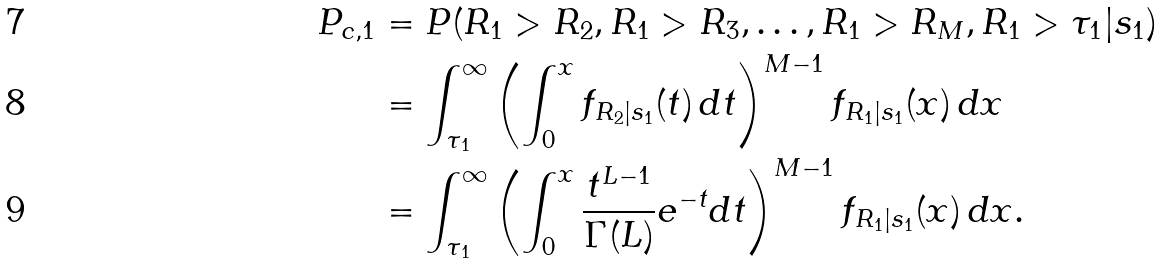<formula> <loc_0><loc_0><loc_500><loc_500>P _ { c , 1 } & = P ( R _ { 1 } > R _ { 2 } , R _ { 1 } > R _ { 3 } , \dots , R _ { 1 } > R _ { M } , R _ { 1 } > \tau _ { 1 } | s _ { 1 } ) \\ & = \int _ { \tau { _ { 1 } } } ^ { \infty } \left ( \int _ { 0 } ^ { x } f _ { R _ { 2 } | s _ { 1 } } ( t ) \, d t \right ) ^ { M - 1 } f _ { R _ { 1 } | s _ { 1 } } ( x ) \, d x \\ & = \int _ { \tau { _ { 1 } } } ^ { \infty } \left ( \int _ { 0 } ^ { x } \frac { t ^ { L - 1 } } { \Gamma ( L ) } e ^ { - t } d t \right ) ^ { M - 1 } f _ { R _ { 1 } | s _ { 1 } } ( x ) \, d x .</formula> 